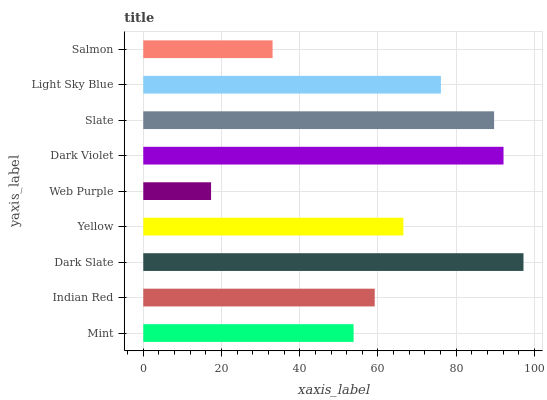Is Web Purple the minimum?
Answer yes or no. Yes. Is Dark Slate the maximum?
Answer yes or no. Yes. Is Indian Red the minimum?
Answer yes or no. No. Is Indian Red the maximum?
Answer yes or no. No. Is Indian Red greater than Mint?
Answer yes or no. Yes. Is Mint less than Indian Red?
Answer yes or no. Yes. Is Mint greater than Indian Red?
Answer yes or no. No. Is Indian Red less than Mint?
Answer yes or no. No. Is Yellow the high median?
Answer yes or no. Yes. Is Yellow the low median?
Answer yes or no. Yes. Is Light Sky Blue the high median?
Answer yes or no. No. Is Web Purple the low median?
Answer yes or no. No. 